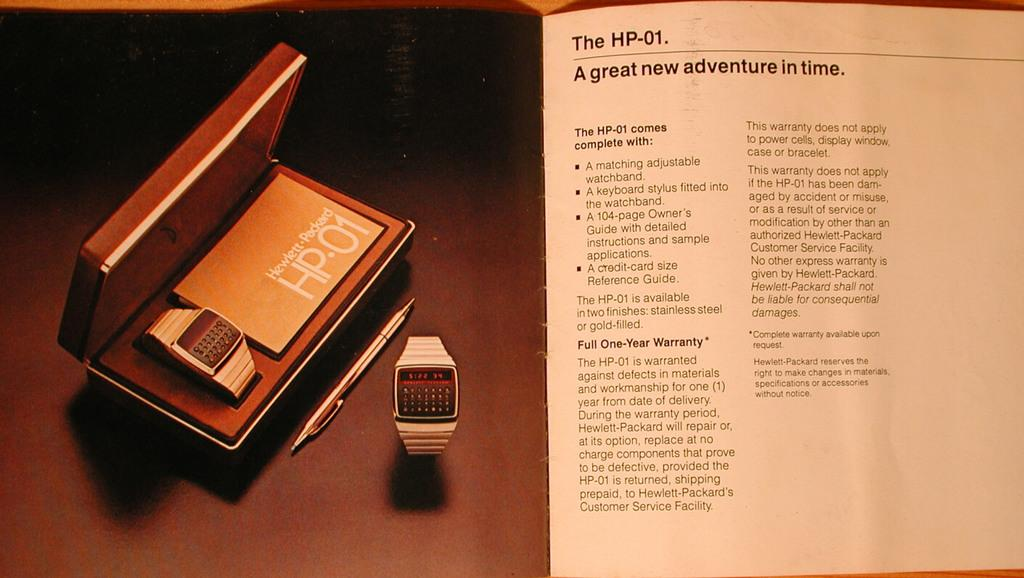What object can be seen in the image that is used for telling time? There is a watch in the image that is used for telling time. What is the watch stored in, as seen in the image? The watch is stored in a box in the image. What type of document is present in the image that provides instructions? There is a user manual in the image that provides instructions. What can be found on the user manual in the image? The user manual has text on it in the image. What is the color of the surface that the watch box is placed on? The watch box is placed on a brown surface in the image. What type of fold can be seen in the image? There is no fold present in the image. What tool is used for tightening bolts in the image? There is no wrench present in the image. 